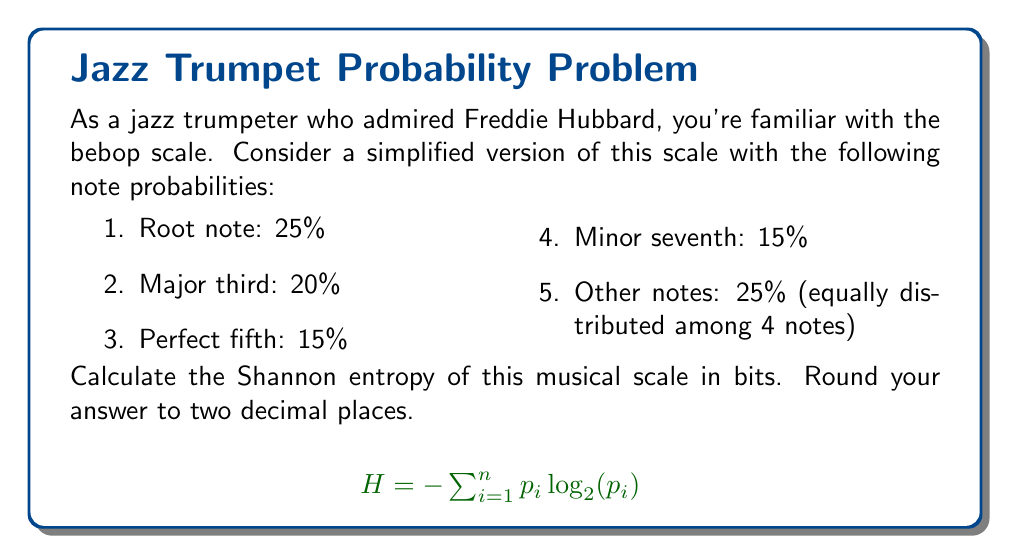Solve this math problem. Let's approach this step-by-step:

1. Recall the formula for Shannon entropy:
   $$H = -\sum_{i=1}^n p_i \log_2(p_i)$$
   where $p_i$ is the probability of each event.

2. We have the following probabilities:
   $p_1 = 0.25$ (root note)
   $p_2 = 0.20$ (major third)
   $p_3 = 0.15$ (perfect fifth)
   $p_4 = 0.15$ (minor seventh)
   $p_5 = p_6 = p_7 = p_8 = 0.25/4 = 0.0625$ (other notes)

3. Let's calculate each term:
   $-0.25 \log_2(0.25) = 0.5$
   $-0.20 \log_2(0.20) = 0.4644$
   $-0.15 \log_2(0.15) = 0.4101$
   $-0.15 \log_2(0.15) = 0.4101$
   $-0.0625 \log_2(0.0625) = 0.2500$ (this term appears 4 times)

4. Sum all terms:
   $H = 0.5 + 0.4644 + 0.4101 + 0.4101 + 4(0.2500) = 2.8346$

5. Rounding to two decimal places:
   $H \approx 2.83$ bits
Answer: 2.83 bits 